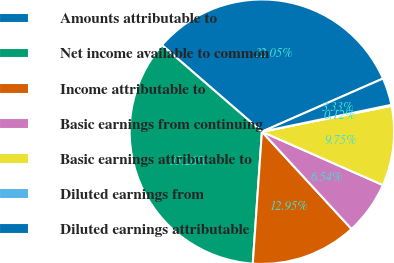Convert chart to OTSL. <chart><loc_0><loc_0><loc_500><loc_500><pie_chart><fcel>Amounts attributable to<fcel>Net income available to common<fcel>Income attributable to<fcel>Basic earnings from continuing<fcel>Basic earnings attributable to<fcel>Diluted earnings from<fcel>Diluted earnings attributable<nl><fcel>32.05%<fcel>35.26%<fcel>12.95%<fcel>6.54%<fcel>9.75%<fcel>0.12%<fcel>3.33%<nl></chart> 